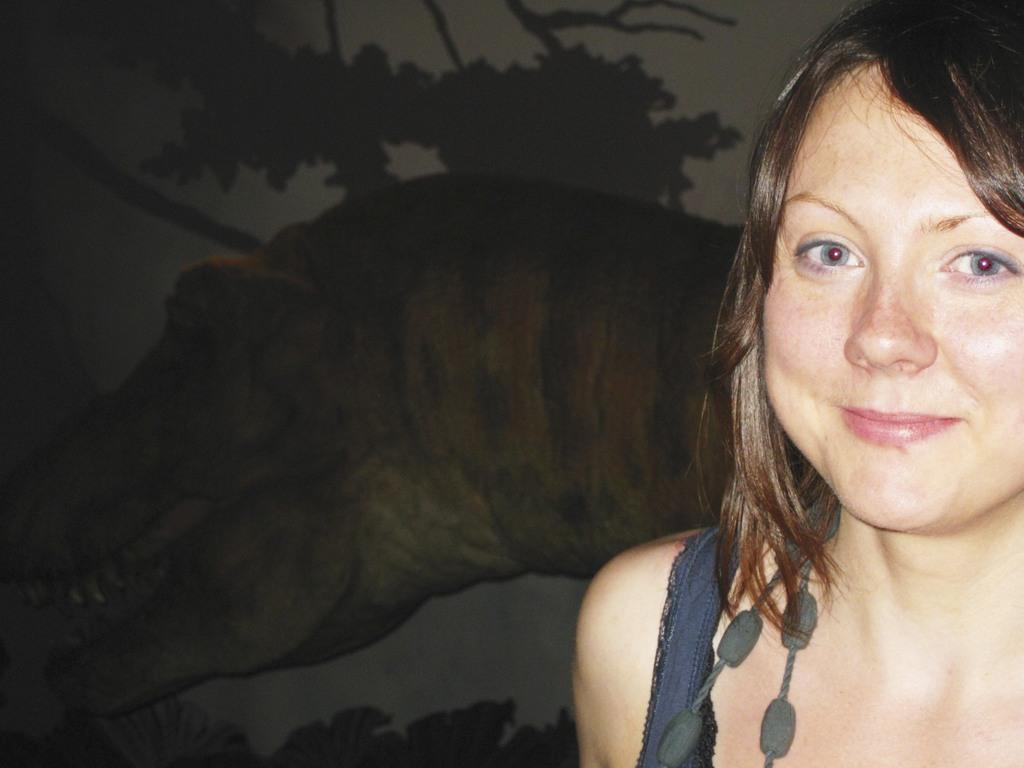Who is present in the image? There is a woman in the image. What is the woman's expression? The woman is smiling. What can be seen in the background of the image? There is a crocodile in the background of the image. What color are the objects on the woman? The objects on the woman are black. What level of thought is the woman demonstrating in the image? The image does not provide information about the level of thought the woman is demonstrating. 